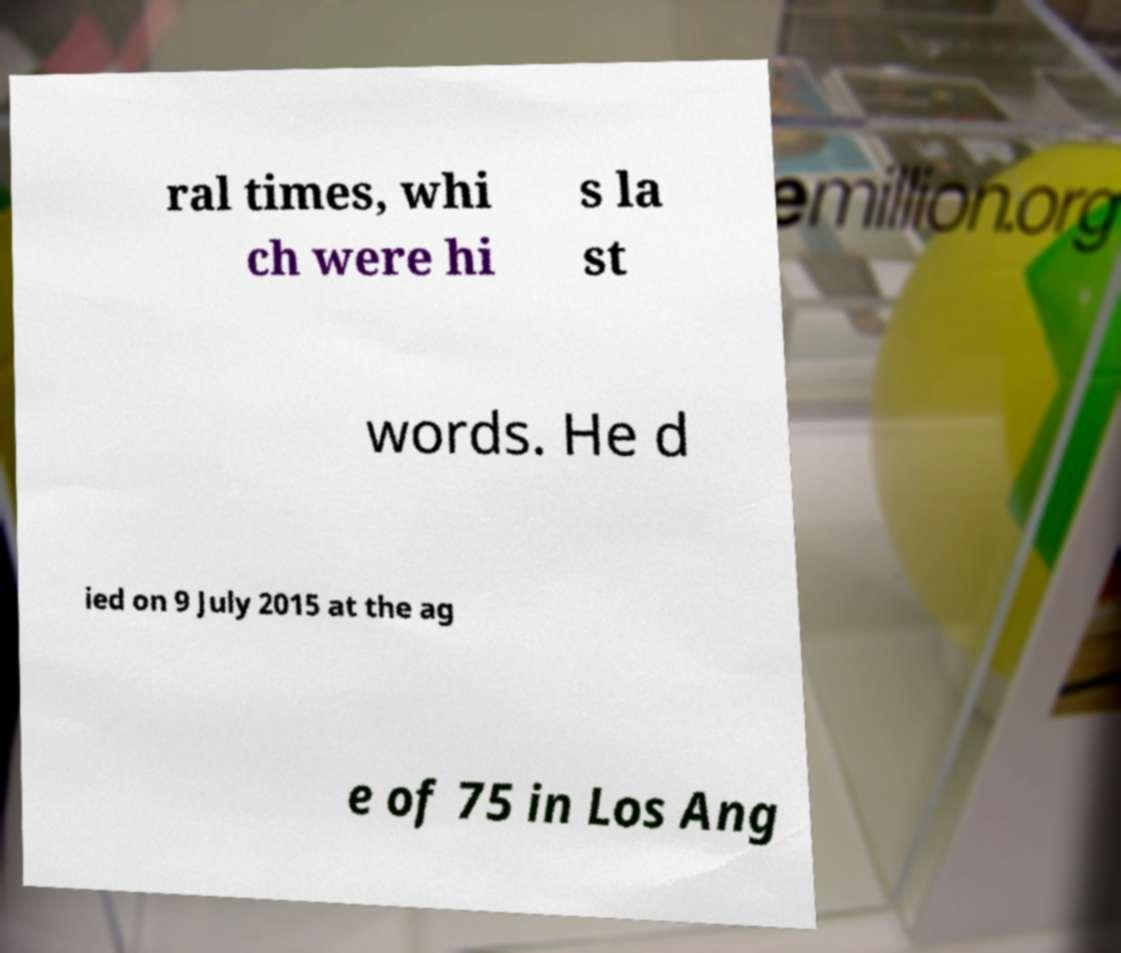Could you extract and type out the text from this image? ral times, whi ch were hi s la st words. He d ied on 9 July 2015 at the ag e of 75 in Los Ang 